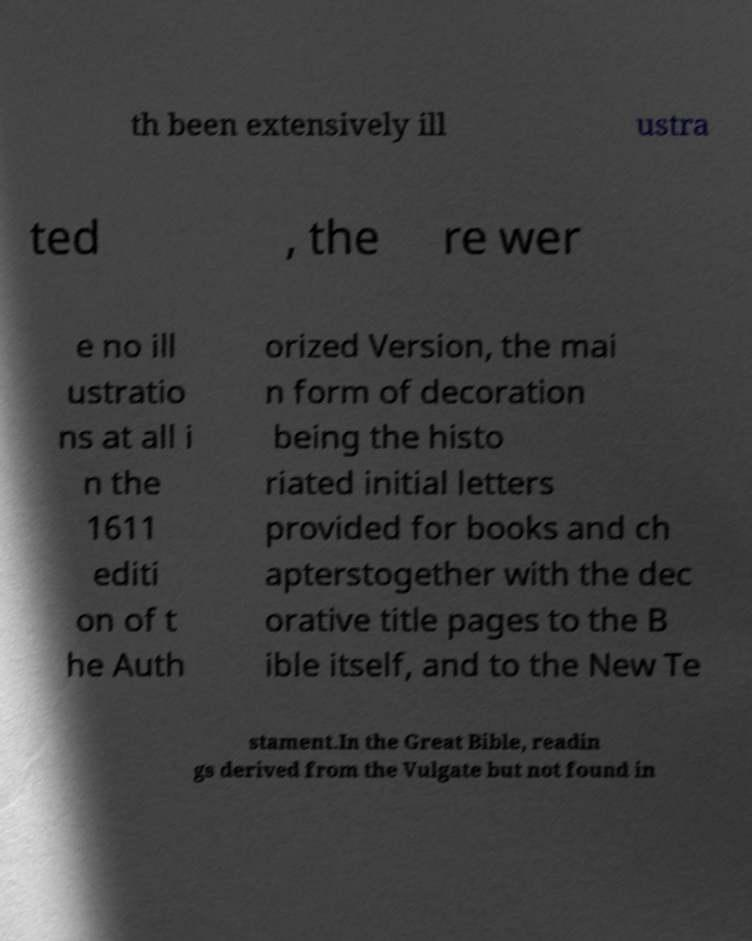I need the written content from this picture converted into text. Can you do that? th been extensively ill ustra ted , the re wer e no ill ustratio ns at all i n the 1611 editi on of t he Auth orized Version, the mai n form of decoration being the histo riated initial letters provided for books and ch apterstogether with the dec orative title pages to the B ible itself, and to the New Te stament.In the Great Bible, readin gs derived from the Vulgate but not found in 